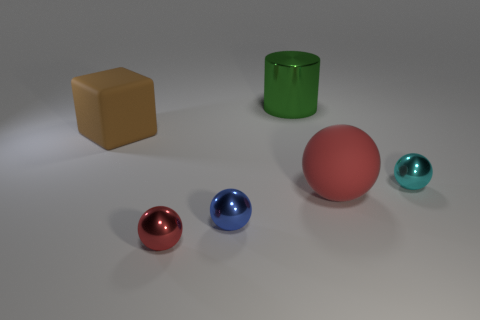Are there any other things of the same color as the large matte sphere?
Provide a succinct answer. Yes. What is the size of the object that is the same material as the big red sphere?
Offer a terse response. Large. What is the material of the big object in front of the tiny cyan shiny object that is behind the red object to the left of the large green thing?
Your response must be concise. Rubber. Is the number of big green blocks less than the number of large red rubber objects?
Ensure brevity in your answer.  Yes. Is the material of the brown object the same as the tiny blue thing?
Give a very brief answer. No. The object that is the same color as the rubber sphere is what shape?
Your response must be concise. Sphere. Is the color of the metallic sphere that is to the right of the rubber sphere the same as the big block?
Your answer should be compact. No. There is a large object that is in front of the brown rubber block; how many large metallic things are behind it?
Offer a very short reply. 1. What is the color of the rubber ball that is the same size as the green cylinder?
Give a very brief answer. Red. What is the red sphere behind the blue thing made of?
Ensure brevity in your answer.  Rubber. 